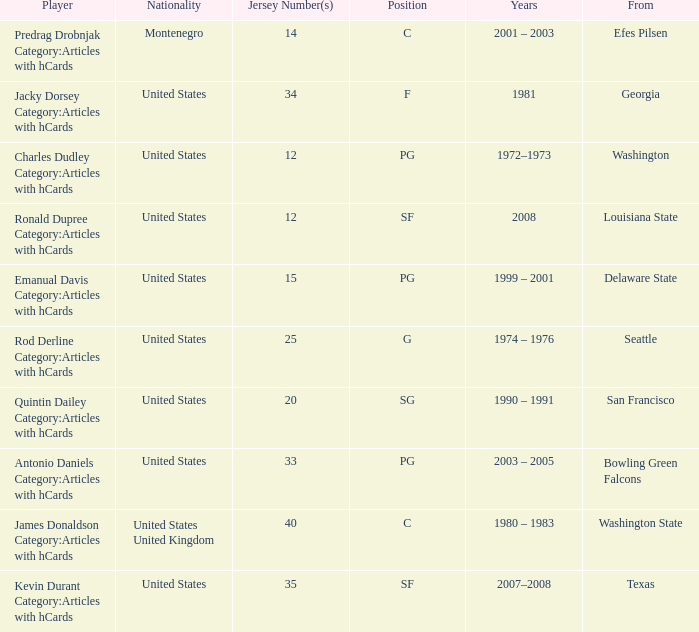Of the players in the "g" position, what was their nationality? United States. 